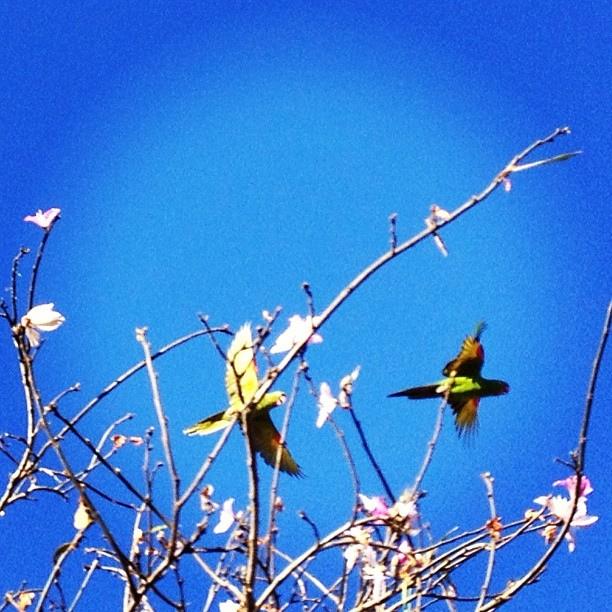What is in the picture?
Concise answer only. Birds. How many birds are seen?
Short answer required. 2. Is the sky clear?
Answer briefly. Yes. 